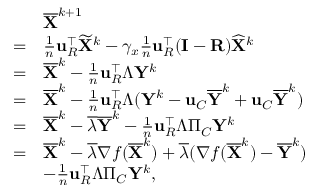Convert formula to latex. <formula><loc_0><loc_0><loc_500><loc_500>\begin{array} { r l } & { \overline { X } ^ { k + 1 } } \\ { = } & { \frac { 1 } { n } { u } _ { R } ^ { \intercal } \widetilde { X } ^ { k } - \gamma _ { x } \frac { 1 } { n } { u } _ { R } ^ { \intercal } ( { I } - { R } ) \widehat { X } ^ { k } } \\ { = } & { \overline { X } ^ { k } - \frac { 1 } { n } { u } _ { R } ^ { \intercal } \Lambda { Y } ^ { k } } \\ { = } & { \overline { X } ^ { k } - \frac { 1 } { n } { u } _ { R } ^ { \intercal } \Lambda ( { Y } ^ { k } - { u } _ { C } \overline { Y } ^ { k } + { u } _ { C } \overline { Y } ^ { k } ) } \\ { = } & { \overline { X } ^ { k } - \overline { \lambda } \overline { Y } ^ { k } - \frac { 1 } { n } { u } _ { R } ^ { \intercal } \Lambda \Pi _ { C } { Y } ^ { k } } \\ { = } & { \overline { X } ^ { k } - \overline { \lambda } \nabla f ( \overline { X } ^ { k } ) + \overline { \lambda } ( \nabla f ( \overline { X } ^ { k } ) - \overline { Y } ^ { k } ) } \\ & { - \frac { 1 } { n } { u } _ { R } ^ { \intercal } \Lambda \Pi _ { C } { Y } ^ { k } , } \end{array}</formula> 